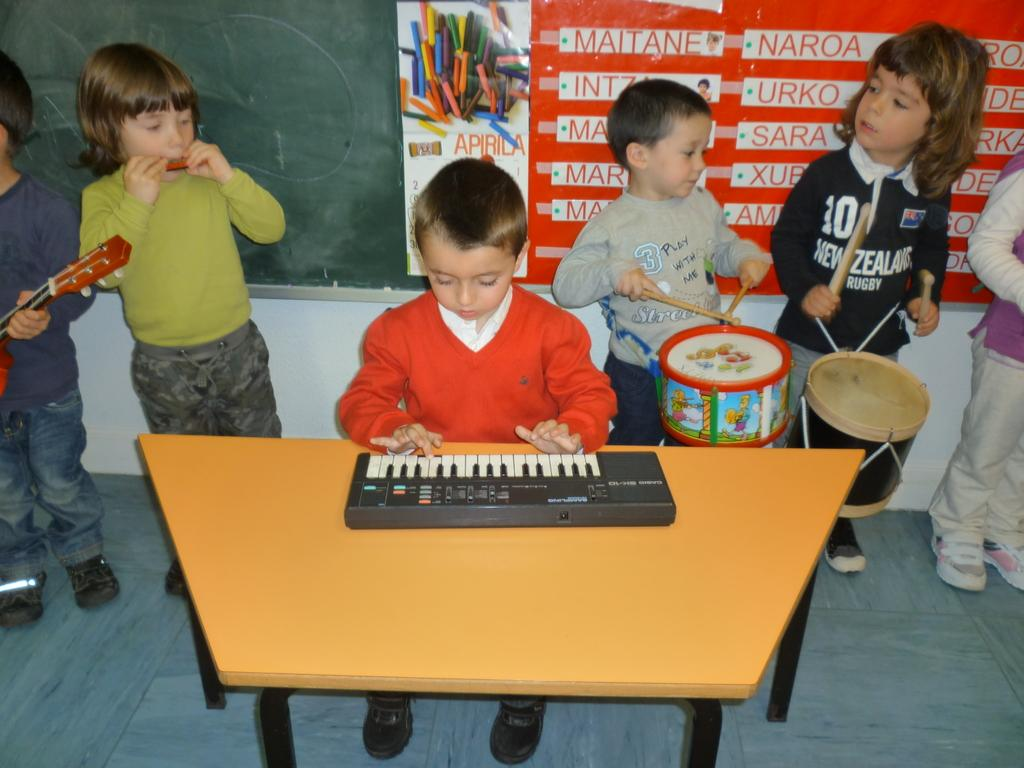How many children are in the image? There are many children in the image. What is one child doing in the image? One child is sitting on a chair. What instrument is the child playing? The child is playing a piano. Where is the piano located in relation to the child? The piano is on a table in front of the child. What type of fiction does the child's mom write? There is no mention of a mom or any fiction in the image, so it cannot be determined from the image. 